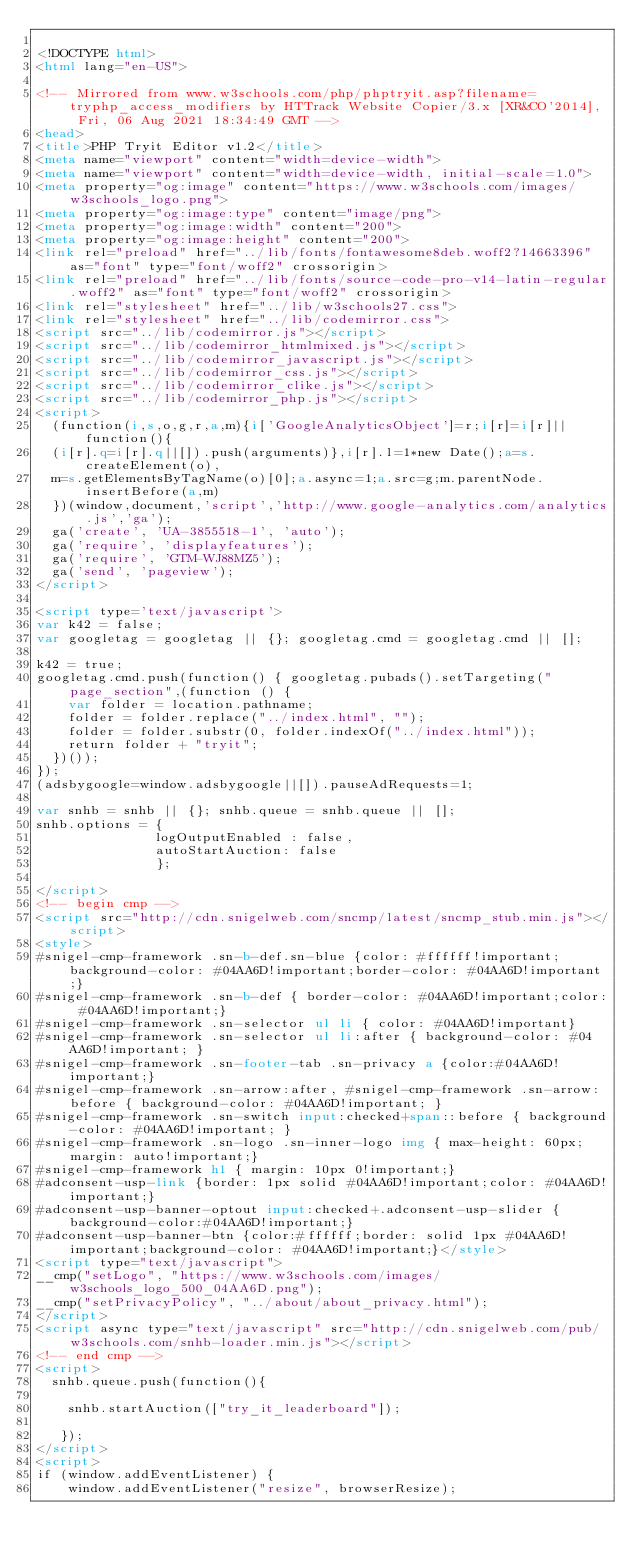<code> <loc_0><loc_0><loc_500><loc_500><_HTML_>
<!DOCTYPE html>
<html lang="en-US">

<!-- Mirrored from www.w3schools.com/php/phptryit.asp?filename=tryphp_access_modifiers by HTTrack Website Copier/3.x [XR&CO'2014], Fri, 06 Aug 2021 18:34:49 GMT -->
<head>
<title>PHP Tryit Editor v1.2</title>
<meta name="viewport" content="width=device-width">
<meta name="viewport" content="width=device-width, initial-scale=1.0">
<meta property="og:image" content="https://www.w3schools.com/images/w3schools_logo.png">
<meta property="og:image:type" content="image/png">
<meta property="og:image:width" content="200">
<meta property="og:image:height" content="200">
<link rel="preload" href="../lib/fonts/fontawesome8deb.woff2?14663396" as="font" type="font/woff2" crossorigin> 
<link rel="preload" href="../lib/fonts/source-code-pro-v14-latin-regular.woff2" as="font" type="font/woff2" crossorigin> 
<link rel="stylesheet" href="../lib/w3schools27.css">
<link rel="stylesheet" href="../lib/codemirror.css">
<script src="../lib/codemirror.js"></script>
<script src="../lib/codemirror_htmlmixed.js"></script>
<script src="../lib/codemirror_javascript.js"></script>
<script src="../lib/codemirror_css.js"></script>
<script src="../lib/codemirror_clike.js"></script>
<script src="../lib/codemirror_php.js"></script>
<script>
  (function(i,s,o,g,r,a,m){i['GoogleAnalyticsObject']=r;i[r]=i[r]||function(){
  (i[r].q=i[r].q||[]).push(arguments)},i[r].l=1*new Date();a=s.createElement(o),
  m=s.getElementsByTagName(o)[0];a.async=1;a.src=g;m.parentNode.insertBefore(a,m)
  })(window,document,'script','http://www.google-analytics.com/analytics.js','ga');
  ga('create', 'UA-3855518-1', 'auto');
  ga('require', 'displayfeatures');
  ga('require', 'GTM-WJ88MZ5');
  ga('send', 'pageview');
</script>

<script type='text/javascript'>
var k42 = false;
var googletag = googletag || {}; googletag.cmd = googletag.cmd || [];

k42 = true;
googletag.cmd.push(function() { googletag.pubads().setTargeting("page_section",(function () {
    var folder = location.pathname;
    folder = folder.replace("../index.html", "");
    folder = folder.substr(0, folder.indexOf("../index.html"));
    return folder + "tryit";
  })());
});
(adsbygoogle=window.adsbygoogle||[]).pauseAdRequests=1;

var snhb = snhb || {}; snhb.queue = snhb.queue || [];
snhb.options = {
               logOutputEnabled : false,
               autoStartAuction: false
               };

</script>
<!-- begin cmp -->
<script src="http://cdn.snigelweb.com/sncmp/latest/sncmp_stub.min.js"></script>
<style>
#snigel-cmp-framework .sn-b-def.sn-blue {color: #ffffff!important;background-color: #04AA6D!important;border-color: #04AA6D!important;}
#snigel-cmp-framework .sn-b-def { border-color: #04AA6D!important;color: #04AA6D!important;}
#snigel-cmp-framework .sn-selector ul li { color: #04AA6D!important}
#snigel-cmp-framework .sn-selector ul li:after { background-color: #04AA6D!important; }
#snigel-cmp-framework .sn-footer-tab .sn-privacy a {color:#04AA6D!important;}
#snigel-cmp-framework .sn-arrow:after, #snigel-cmp-framework .sn-arrow:before { background-color: #04AA6D!important; }
#snigel-cmp-framework .sn-switch input:checked+span::before { background-color: #04AA6D!important; }
#snigel-cmp-framework .sn-logo .sn-inner-logo img { max-height: 60px; margin: auto!important;}
#snigel-cmp-framework h1 { margin: 10px 0!important;}
#adconsent-usp-link {border: 1px solid #04AA6D!important;color: #04AA6D!important;}
#adconsent-usp-banner-optout input:checked+.adconsent-usp-slider {background-color:#04AA6D!important;}
#adconsent-usp-banner-btn {color:#ffffff;border: solid 1px #04AA6D!important;background-color: #04AA6D!important;}</style>
<script type="text/javascript">
__cmp("setLogo", "https://www.w3schools.com/images/w3schools_logo_500_04AA6D.png");
__cmp("setPrivacyPolicy", "../about/about_privacy.html");
</script>
<script async type="text/javascript" src="http://cdn.snigelweb.com/pub/w3schools.com/snhb-loader.min.js"></script>
<!-- end cmp -->
<script>
  snhb.queue.push(function(){

    snhb.startAuction(["try_it_leaderboard"]);

   });
</script>
<script>
if (window.addEventListener) {              
    window.addEventListener("resize", browserResize);</code> 